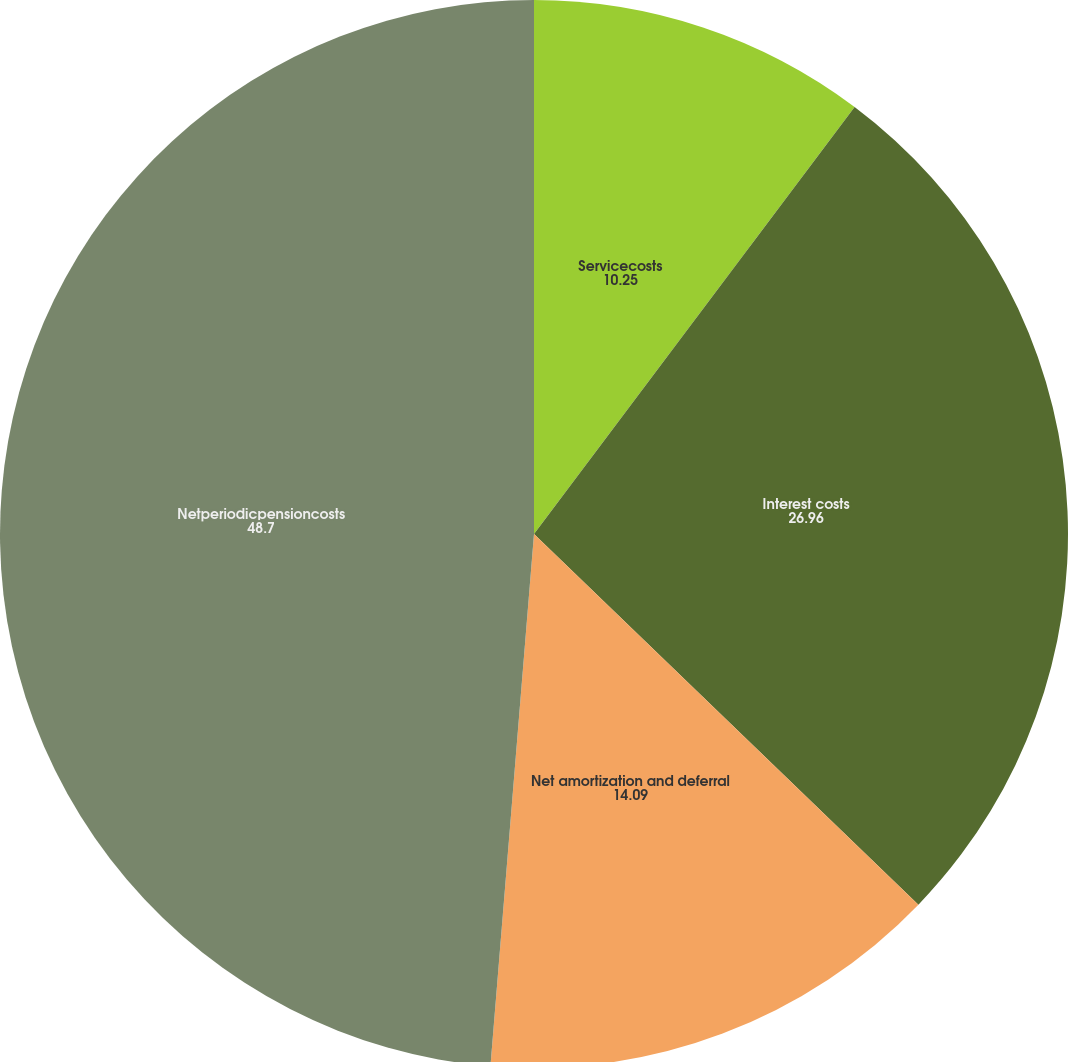<chart> <loc_0><loc_0><loc_500><loc_500><pie_chart><fcel>Servicecosts<fcel>Interest costs<fcel>Net amortization and deferral<fcel>Netperiodicpensioncosts<nl><fcel>10.25%<fcel>26.96%<fcel>14.09%<fcel>48.7%<nl></chart> 